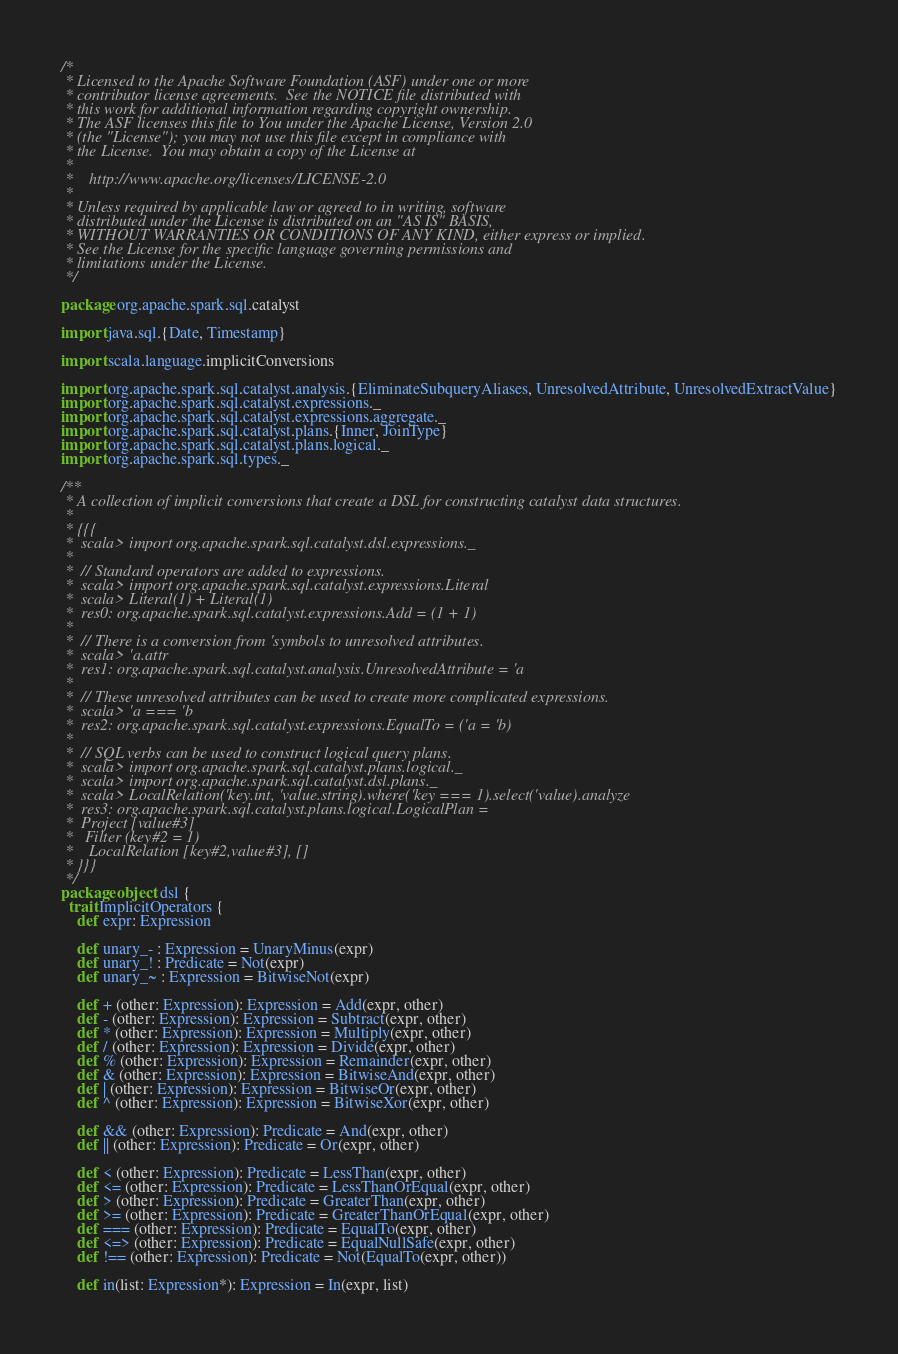Convert code to text. <code><loc_0><loc_0><loc_500><loc_500><_Scala_>/*
 * Licensed to the Apache Software Foundation (ASF) under one or more
 * contributor license agreements.  See the NOTICE file distributed with
 * this work for additional information regarding copyright ownership.
 * The ASF licenses this file to You under the Apache License, Version 2.0
 * (the "License"); you may not use this file except in compliance with
 * the License.  You may obtain a copy of the License at
 *
 *    http://www.apache.org/licenses/LICENSE-2.0
 *
 * Unless required by applicable law or agreed to in writing, software
 * distributed under the License is distributed on an "AS IS" BASIS,
 * WITHOUT WARRANTIES OR CONDITIONS OF ANY KIND, either express or implied.
 * See the License for the specific language governing permissions and
 * limitations under the License.
 */

package org.apache.spark.sql.catalyst

import java.sql.{Date, Timestamp}

import scala.language.implicitConversions

import org.apache.spark.sql.catalyst.analysis.{EliminateSubqueryAliases, UnresolvedAttribute, UnresolvedExtractValue}
import org.apache.spark.sql.catalyst.expressions._
import org.apache.spark.sql.catalyst.expressions.aggregate._
import org.apache.spark.sql.catalyst.plans.{Inner, JoinType}
import org.apache.spark.sql.catalyst.plans.logical._
import org.apache.spark.sql.types._

/**
 * A collection of implicit conversions that create a DSL for constructing catalyst data structures.
 *
 * {{{
 *  scala> import org.apache.spark.sql.catalyst.dsl.expressions._
 *
 *  // Standard operators are added to expressions.
 *  scala> import org.apache.spark.sql.catalyst.expressions.Literal
 *  scala> Literal(1) + Literal(1)
 *  res0: org.apache.spark.sql.catalyst.expressions.Add = (1 + 1)
 *
 *  // There is a conversion from 'symbols to unresolved attributes.
 *  scala> 'a.attr
 *  res1: org.apache.spark.sql.catalyst.analysis.UnresolvedAttribute = 'a
 *
 *  // These unresolved attributes can be used to create more complicated expressions.
 *  scala> 'a === 'b
 *  res2: org.apache.spark.sql.catalyst.expressions.EqualTo = ('a = 'b)
 *
 *  // SQL verbs can be used to construct logical query plans.
 *  scala> import org.apache.spark.sql.catalyst.plans.logical._
 *  scala> import org.apache.spark.sql.catalyst.dsl.plans._
 *  scala> LocalRelation('key.int, 'value.string).where('key === 1).select('value).analyze
 *  res3: org.apache.spark.sql.catalyst.plans.logical.LogicalPlan =
 *  Project [value#3]
 *   Filter (key#2 = 1)
 *    LocalRelation [key#2,value#3], []
 * }}}
 */
package object dsl {
  trait ImplicitOperators {
    def expr: Expression

    def unary_- : Expression = UnaryMinus(expr)
    def unary_! : Predicate = Not(expr)
    def unary_~ : Expression = BitwiseNot(expr)

    def + (other: Expression): Expression = Add(expr, other)
    def - (other: Expression): Expression = Subtract(expr, other)
    def * (other: Expression): Expression = Multiply(expr, other)
    def / (other: Expression): Expression = Divide(expr, other)
    def % (other: Expression): Expression = Remainder(expr, other)
    def & (other: Expression): Expression = BitwiseAnd(expr, other)
    def | (other: Expression): Expression = BitwiseOr(expr, other)
    def ^ (other: Expression): Expression = BitwiseXor(expr, other)

    def && (other: Expression): Predicate = And(expr, other)
    def || (other: Expression): Predicate = Or(expr, other)

    def < (other: Expression): Predicate = LessThan(expr, other)
    def <= (other: Expression): Predicate = LessThanOrEqual(expr, other)
    def > (other: Expression): Predicate = GreaterThan(expr, other)
    def >= (other: Expression): Predicate = GreaterThanOrEqual(expr, other)
    def === (other: Expression): Predicate = EqualTo(expr, other)
    def <=> (other: Expression): Predicate = EqualNullSafe(expr, other)
    def !== (other: Expression): Predicate = Not(EqualTo(expr, other))

    def in(list: Expression*): Expression = In(expr, list)
</code> 